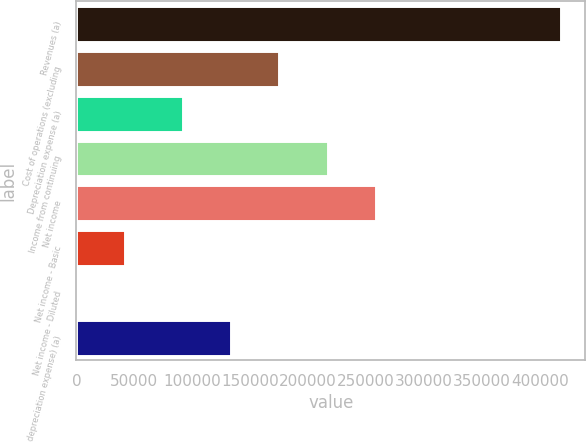<chart> <loc_0><loc_0><loc_500><loc_500><bar_chart><fcel>Revenues (a)<fcel>Cost of operations (excluding<fcel>Depreciation expense (a)<fcel>Income from continuing<fcel>Net income<fcel>Net income - Basic<fcel>Net income - Diluted<fcel>depreciation expense) (a)<nl><fcel>418238<fcel>175294<fcel>91647<fcel>217118<fcel>258942<fcel>41824.4<fcel>0.71<fcel>133471<nl></chart> 